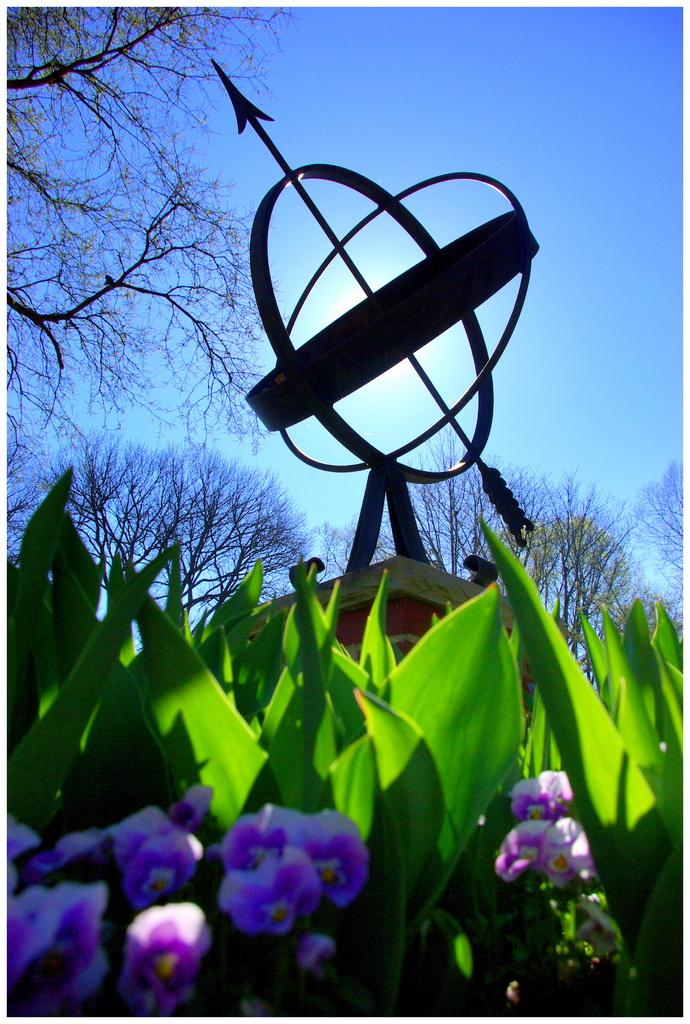What type of plants can be seen in the image? There are plants with flowers in the image. What structure is present in the image? There is a building in the image. What is on the building? There are objects on the building. What type of vegetation is visible in the image? There are trees in the image. What is visible in the background of the image? The sky is visible in the background of the image. What type of knowledge can be seen on the front of the building in the image? There is no knowledge visible on the front of the building in the image. What mark is present on the trees in the image? There are no marks present on the trees in the image. 